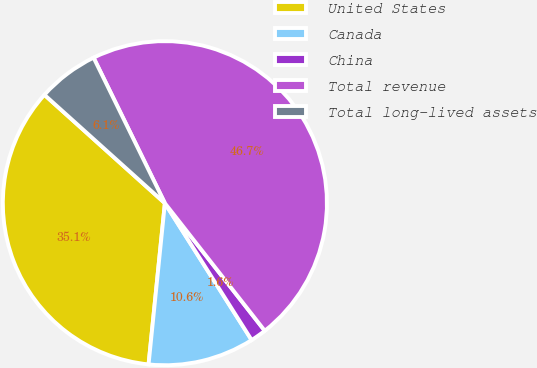<chart> <loc_0><loc_0><loc_500><loc_500><pie_chart><fcel>United States<fcel>Canada<fcel>China<fcel>Total revenue<fcel>Total long-lived assets<nl><fcel>35.06%<fcel>10.6%<fcel>1.58%<fcel>46.69%<fcel>6.09%<nl></chart> 